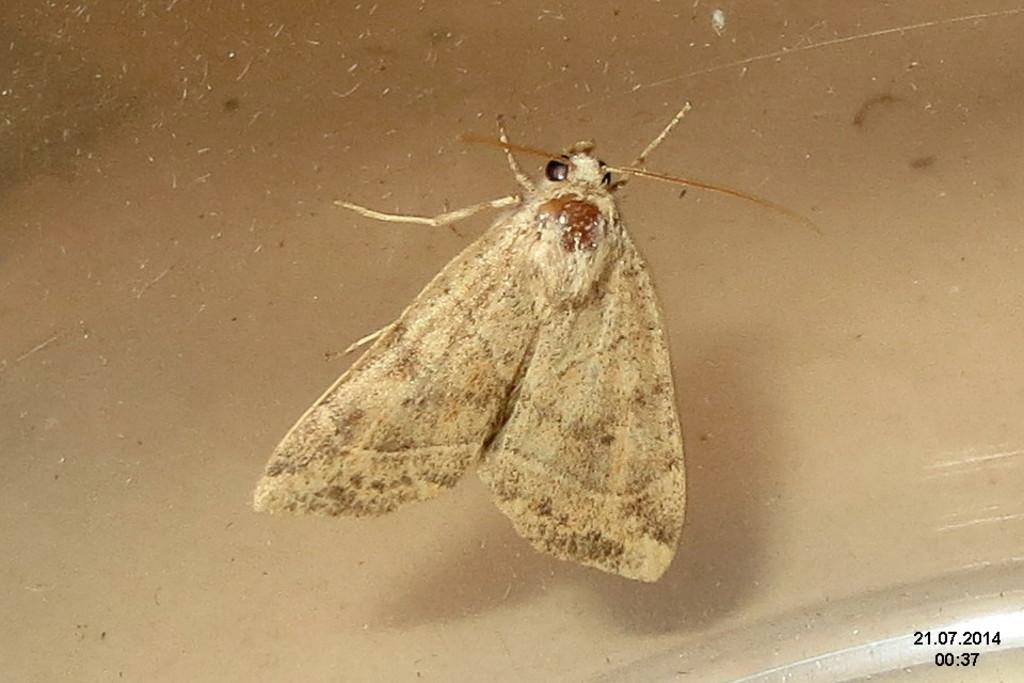What type of creature is present in the image? There is an insect in the image. Where is the insect located? The insect is on the wall. What type of grape can be seen on the shelf in the image? There is no shelf or grape present in the image; it only features an insect on the wall. 